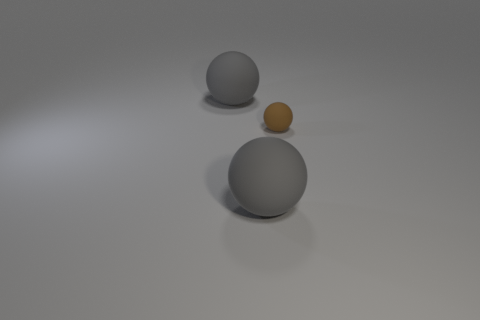Are there any other things that have the same size as the brown sphere?
Your answer should be very brief. No. What number of small brown things have the same material as the tiny sphere?
Ensure brevity in your answer.  0. What number of green objects are balls or small spheres?
Give a very brief answer. 0. Do the thing that is behind the tiny brown matte object and the tiny brown thing have the same material?
Make the answer very short. Yes. How many objects are brown balls or things that are to the left of the brown rubber sphere?
Provide a short and direct response. 3. How many tiny brown spheres are left of the gray matte object on the right side of the big gray matte thing that is behind the small brown rubber ball?
Offer a terse response. 0. There is a big sphere that is behind the brown ball; are there any gray matte spheres that are to the left of it?
Keep it short and to the point. No. What number of matte objects are there?
Provide a short and direct response. 3. What material is the brown ball?
Offer a very short reply. Rubber. Are there any large matte objects to the left of the small brown thing?
Provide a short and direct response. Yes. 